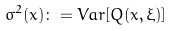Convert formula to latex. <formula><loc_0><loc_0><loc_500><loc_500>\sigma ^ { 2 } ( x ) \colon = V a r [ Q ( x , \xi ) ]</formula> 